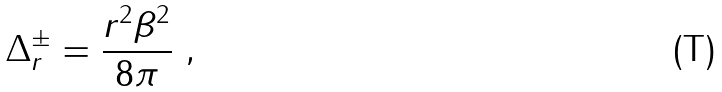Convert formula to latex. <formula><loc_0><loc_0><loc_500><loc_500>\Delta ^ { \pm } _ { r } = \frac { r ^ { 2 } \beta ^ { 2 } } { 8 \pi } \ ,</formula> 